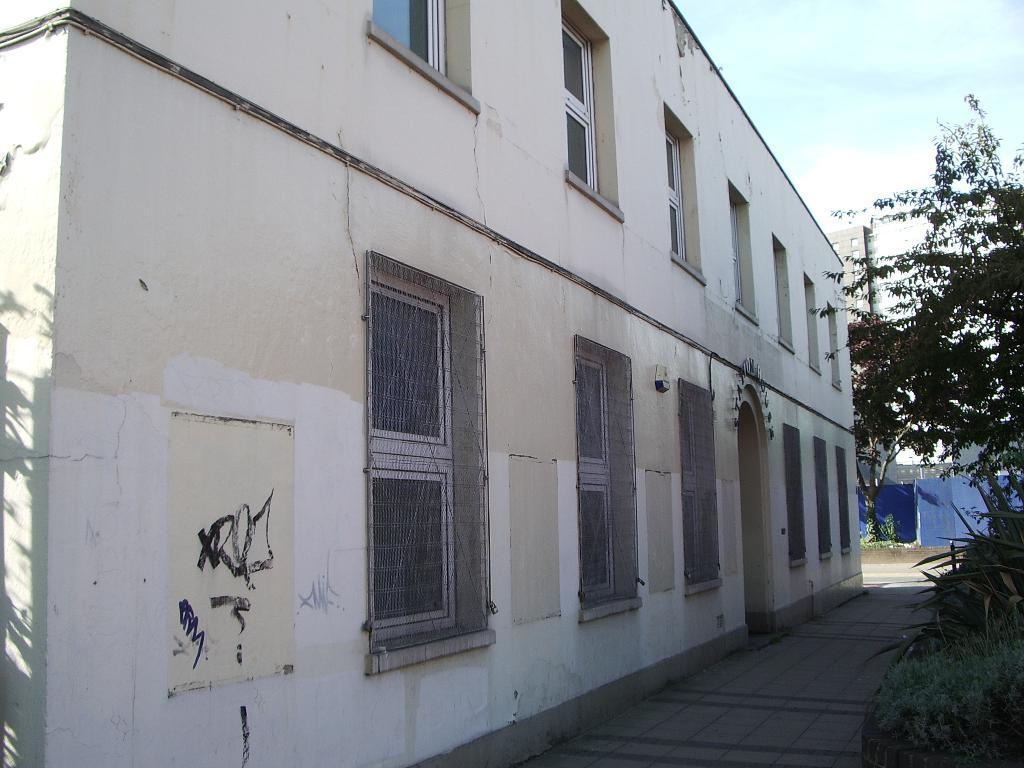What is the main subject in the center of the image? There is a building in the center of the image. What type of vegetation is on the right side of the image? There are trees and grass on the right side of the image. Can you describe the background of the image? There is a building in the background of the image, and the sky is visible as well. How many toes are visible on the building in the image? There are no toes present in the image, as it features buildings and vegetation. 